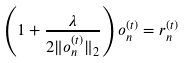<formula> <loc_0><loc_0><loc_500><loc_500>\left ( 1 + \frac { \lambda } { 2 \| o _ { n } ^ { ( t ) } \| _ { 2 } } \right ) o _ { n } ^ { ( t ) } = r _ { n } ^ { ( t ) }</formula> 